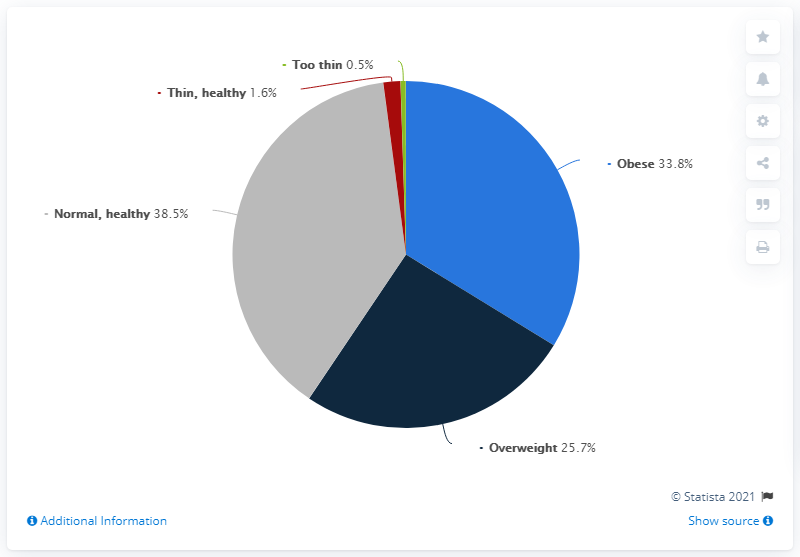Indicate a few pertinent items in this graphic. According to a recent study, approximately 33.8% of cats in the United States are considered obese. It is clear that green has the least number of cats, as stated in the question. 